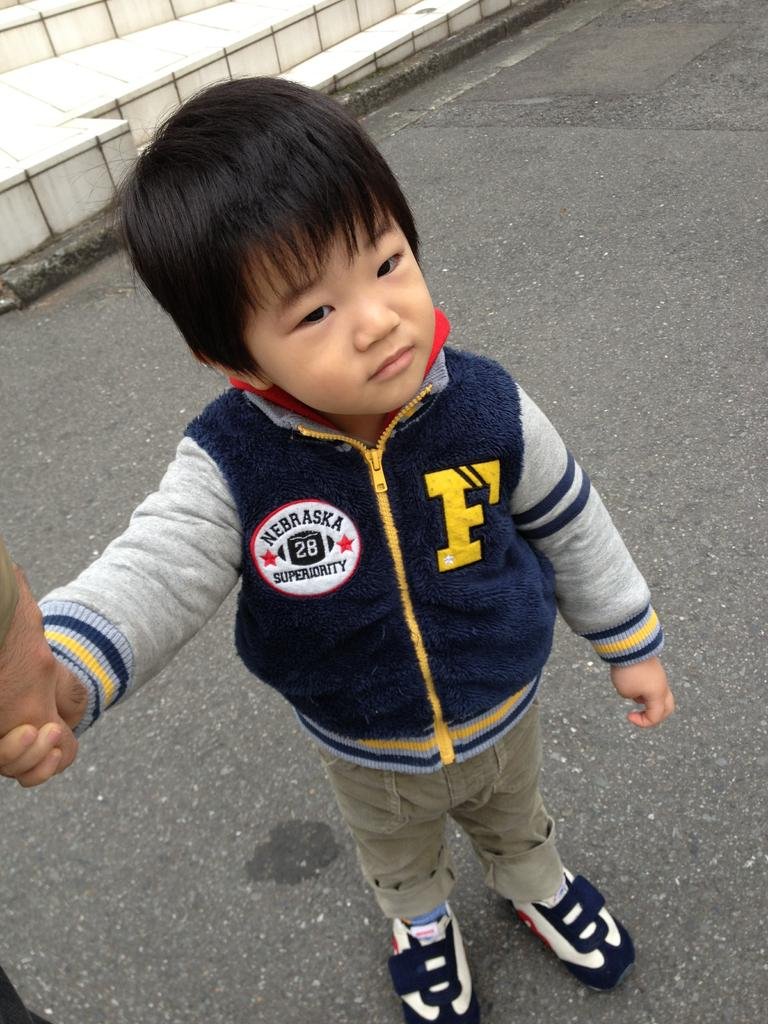<image>
Offer a succinct explanation of the picture presented. Boy wearing a jacket which has the letter F on it. 